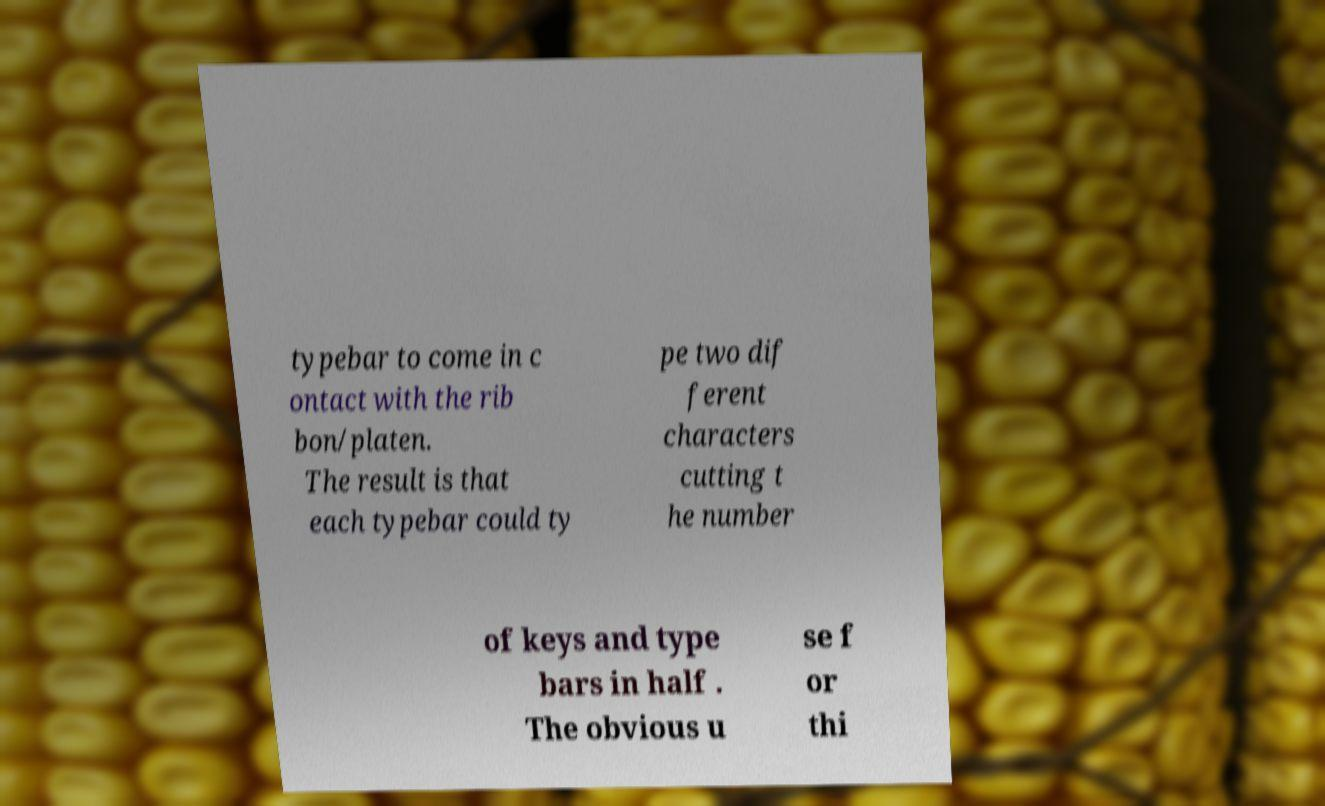Please identify and transcribe the text found in this image. typebar to come in c ontact with the rib bon/platen. The result is that each typebar could ty pe two dif ferent characters cutting t he number of keys and type bars in half . The obvious u se f or thi 